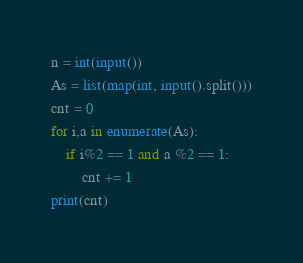Convert code to text. <code><loc_0><loc_0><loc_500><loc_500><_Python_>n = int(input())
As = list(map(int, input().split()))
cnt = 0
for i,a in enumerate(As):
    if i%2 == 1 and a %2 == 1:
        cnt += 1
print(cnt)</code> 